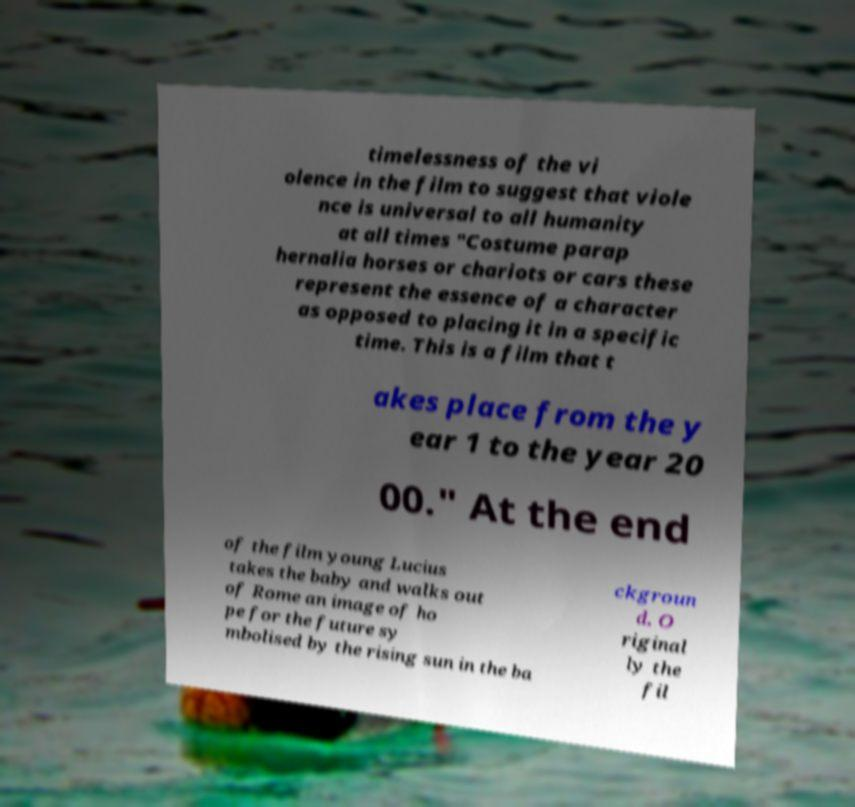Can you read and provide the text displayed in the image?This photo seems to have some interesting text. Can you extract and type it out for me? timelessness of the vi olence in the film to suggest that viole nce is universal to all humanity at all times "Costume parap hernalia horses or chariots or cars these represent the essence of a character as opposed to placing it in a specific time. This is a film that t akes place from the y ear 1 to the year 20 00." At the end of the film young Lucius takes the baby and walks out of Rome an image of ho pe for the future sy mbolised by the rising sun in the ba ckgroun d. O riginal ly the fil 